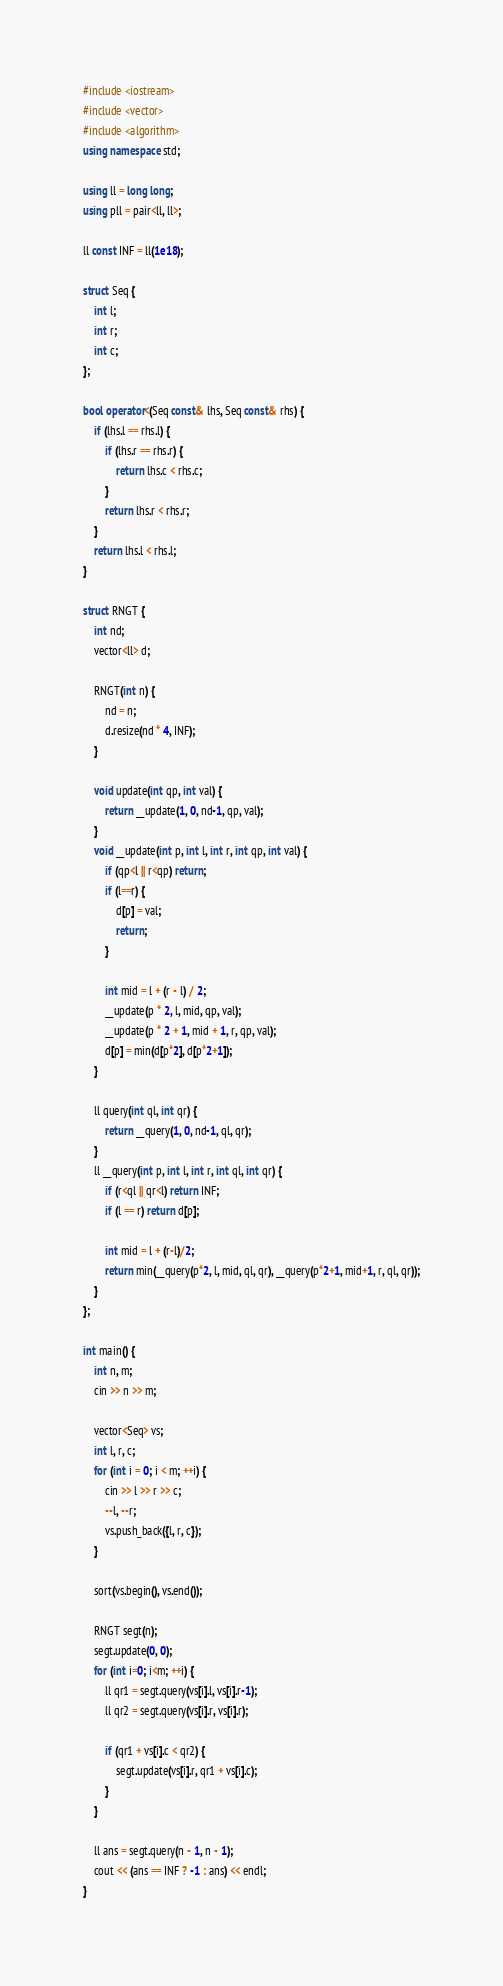Convert code to text. <code><loc_0><loc_0><loc_500><loc_500><_C++_>#include <iostream>
#include <vector>
#include <algorithm>
using namespace std;

using ll = long long;
using pll = pair<ll, ll>;

ll const INF = ll(1e18);

struct Seq {
    int l;
    int r;
    int c;
};

bool operator<(Seq const& lhs, Seq const& rhs) {
    if (lhs.l == rhs.l) {
        if (lhs.r == rhs.r) {
            return lhs.c < rhs.c;
        }
        return lhs.r < rhs.r;
    }
    return lhs.l < rhs.l;
}

struct RNGT {
    int nd;
    vector<ll> d;

    RNGT(int n) {
        nd = n;
        d.resize(nd * 4, INF);
    }

    void update(int qp, int val) {
        return __update(1, 0, nd-1, qp, val);
    }
    void __update(int p, int l, int r, int qp, int val) {
        if (qp<l || r<qp) return;
        if (l==r) {
            d[p] = val;
            return;
        }

        int mid = l + (r - l) / 2;
        __update(p * 2, l, mid, qp, val);
        __update(p * 2 + 1, mid + 1, r, qp, val);
        d[p] = min(d[p*2], d[p*2+1]);
    }

    ll query(int ql, int qr) {
        return __query(1, 0, nd-1, ql, qr);
    }
    ll __query(int p, int l, int r, int ql, int qr) {
        if (r<ql || qr<l) return INF;
        if (l == r) return d[p];

        int mid = l + (r-l)/2;
        return min(__query(p*2, l, mid, ql, qr), __query(p*2+1, mid+1, r, ql, qr));
    }
};

int main() {
    int n, m;
    cin >> n >> m;

    vector<Seq> vs;
    int l, r, c;
    for (int i = 0; i < m; ++i) {
        cin >> l >> r >> c;
        --l, --r;
        vs.push_back({l, r, c});
    }

    sort(vs.begin(), vs.end());

    RNGT segt(n);
    segt.update(0, 0);
    for (int i=0; i<m; ++i) {
        ll qr1 = segt.query(vs[i].l, vs[i].r-1);
        ll qr2 = segt.query(vs[i].r, vs[i].r);

        if (qr1 + vs[i].c < qr2) {
            segt.update(vs[i].r, qr1 + vs[i].c);
        }
    }

    ll ans = segt.query(n - 1, n - 1);
    cout << (ans == INF ? -1 : ans) << endl;
}</code> 